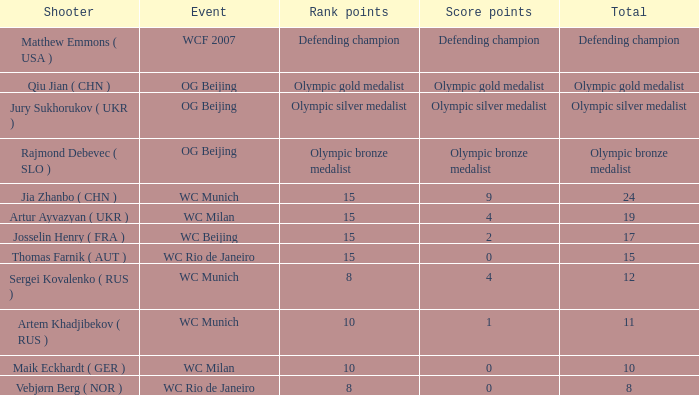Who is the shooter with 15 rank points, and 0 score points? Thomas Farnik ( AUT ). 